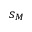Convert formula to latex. <formula><loc_0><loc_0><loc_500><loc_500>s _ { M }</formula> 